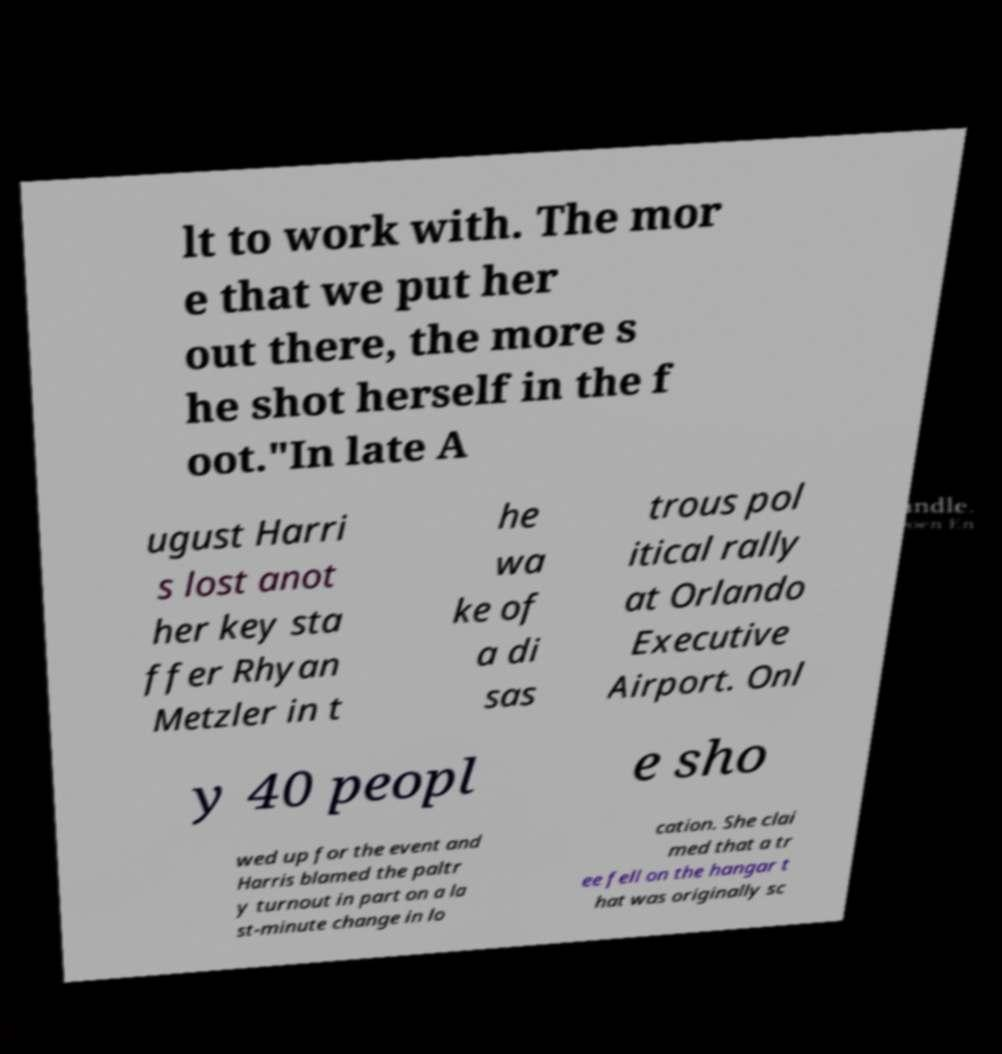What messages or text are displayed in this image? I need them in a readable, typed format. lt to work with. The mor e that we put her out there, the more s he shot herself in the f oot."In late A ugust Harri s lost anot her key sta ffer Rhyan Metzler in t he wa ke of a di sas trous pol itical rally at Orlando Executive Airport. Onl y 40 peopl e sho wed up for the event and Harris blamed the paltr y turnout in part on a la st-minute change in lo cation. She clai med that a tr ee fell on the hangar t hat was originally sc 